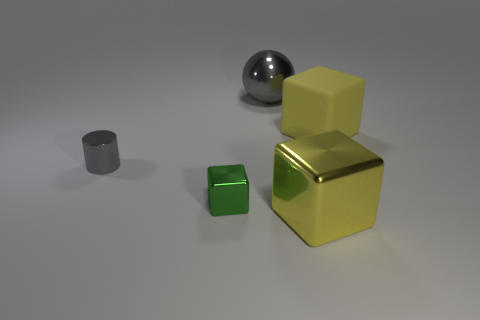Add 1 big spheres. How many objects exist? 6 Subtract all cylinders. How many objects are left? 4 Add 5 small brown metallic cubes. How many small brown metallic cubes exist? 5 Subtract 0 blue blocks. How many objects are left? 5 Subtract all big purple matte cylinders. Subtract all yellow metallic objects. How many objects are left? 4 Add 4 big gray balls. How many big gray balls are left? 5 